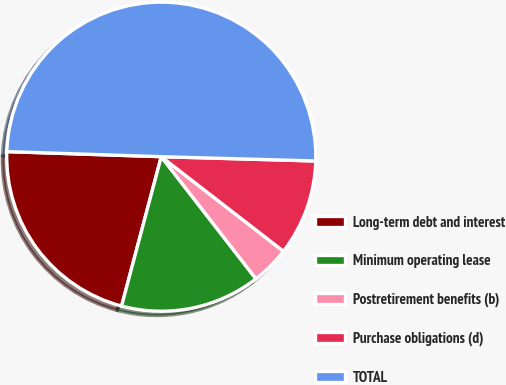<chart> <loc_0><loc_0><loc_500><loc_500><pie_chart><fcel>Long-term debt and interest<fcel>Minimum operating lease<fcel>Postretirement benefits (b)<fcel>Purchase obligations (d)<fcel>TOTAL<nl><fcel>21.39%<fcel>14.63%<fcel>4.02%<fcel>10.04%<fcel>49.92%<nl></chart> 